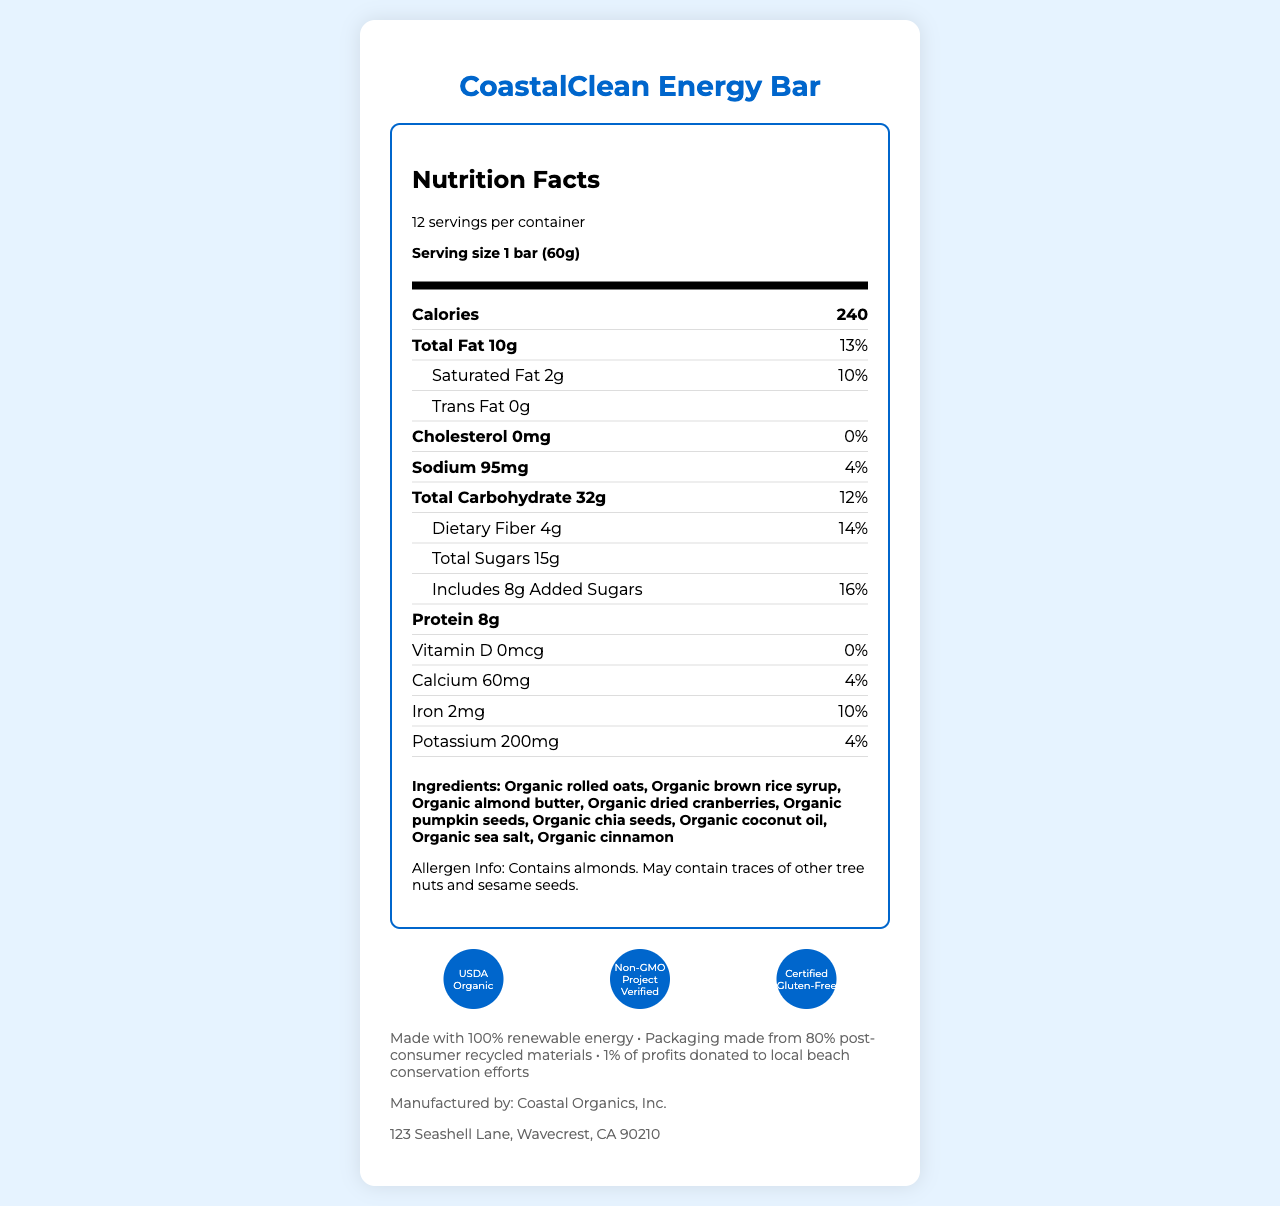what is the serving size of the CoastalClean Energy Bar? The serving size is clearly mentioned on the label as "1 bar (60g)".
Answer: 1 bar (60g) how many calories are in one serving of the CoastalClean Energy Bar? The nutrient row for calories indicates that one serving contains 240 calories.
Answer: 240 calories how much total fat is in one serving of the CoastalClean Energy Bar? The total fat content per serving is listed as 10g.
Answer: 10g which ingredient is listed first on the energy bar? The first ingredient listed is "Organic rolled oats".
Answer: Organic rolled oats who is the manufacturer of the CoastalClean Energy Bar? The manufacturer's name provided at the bottom of the document is Coastal Organics, Inc.
Answer: Coastal Organics, Inc. what is the daily value percentage of dietary fiber in one serving? The label states that one serving provides 14% of the daily value for dietary fiber.
Answer: 14% which of the following nutrients is not present in the CoastalClean Energy Bar? A. Cholesterol B. Trans Fat C. Vitamin D D. Protein Cholesterol is marked as 0mg and 0% daily value, meaning it is not present.
Answer: A what certifications does the CoastalClean Energy Bar have? The certifications listed in the document are USDA Organic, Non-GMO Project Verified, and Certified Gluten-Free.
Answer: USDA Organic, Non-GMO Project Verified, Certified Gluten-Free is the CoastalClean Energy Bar suitable for someone with a peanut allergy? The document says it contains almonds and may contain tree nuts and sesame seeds, but it does not mention peanuts directly.
Answer: Cannot be determined is there any added sugar in the energy bar? It includes 8g of added sugars, as indicated by the nutrient row for sugars.
Answer: Yes what percentage of the daily value for iron does one serving provide? The label indicates that one serving provides 10% of the daily value for iron.
Answer: 10% what is the main idea of the document? The document is focused on presenting all the necessary nutrition and product information in a structured and detailed manner for the CoastalClean Energy Bar.
Answer: The document provides the nutrition facts for the CoastalClean Energy Bar, highlighting ingredients, allergen information, certifications, and additional details about the product. what proportion of the energy bar's packaging is made from post-consumer recycled materials? The additional information at the end states that the packaging is made from 80% post-consumer recycled materials.
Answer: 80% does the CoastalClean Energy Bar contain any gluten? It is certified gluten-free, as indicated in the certifications section.
Answer: No how many servings are in one container of CoastalClean Energy Bars? The document mentions there are 12 servings per container.
Answer: 12 servings 